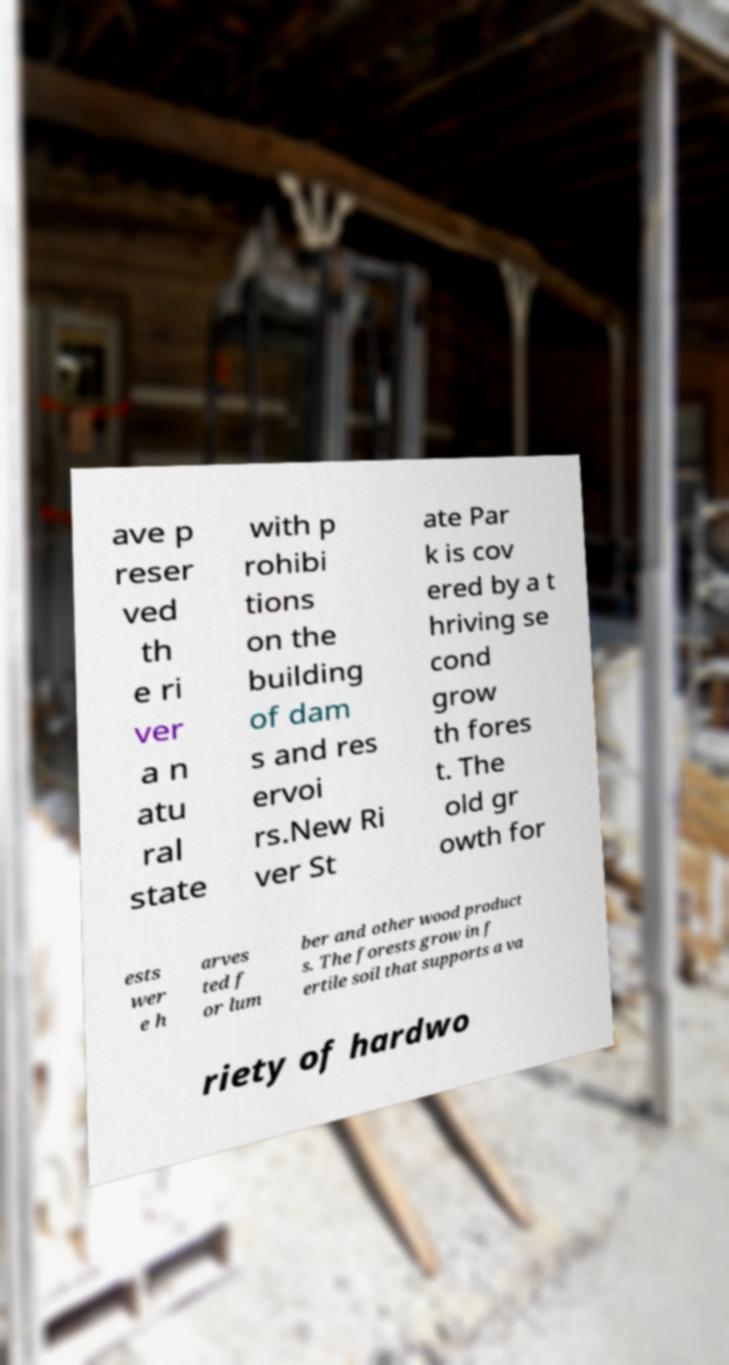For documentation purposes, I need the text within this image transcribed. Could you provide that? ave p reser ved th e ri ver a n atu ral state with p rohibi tions on the building of dam s and res ervoi rs.New Ri ver St ate Par k is cov ered by a t hriving se cond grow th fores t. The old gr owth for ests wer e h arves ted f or lum ber and other wood product s. The forests grow in f ertile soil that supports a va riety of hardwo 